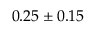<formula> <loc_0><loc_0><loc_500><loc_500>0 . 2 5 \pm 0 . 1 5</formula> 